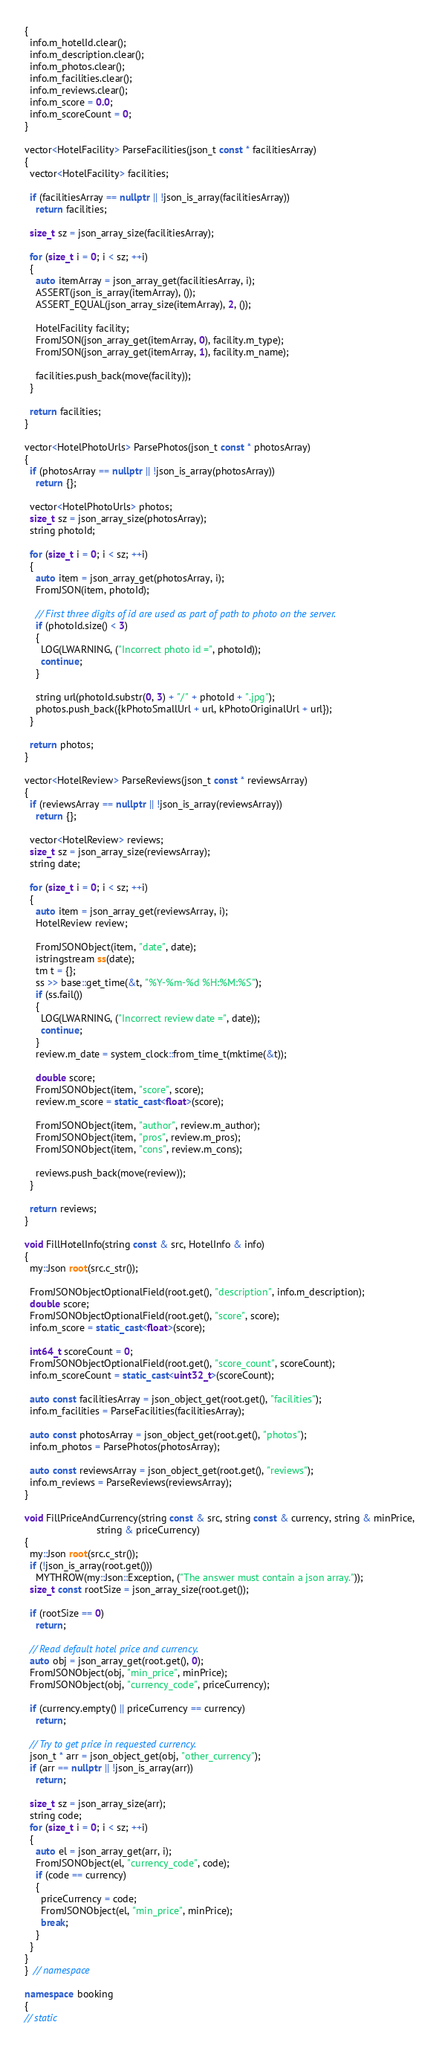Convert code to text. <code><loc_0><loc_0><loc_500><loc_500><_C++_>{
  info.m_hotelId.clear();
  info.m_description.clear();
  info.m_photos.clear();
  info.m_facilities.clear();
  info.m_reviews.clear();
  info.m_score = 0.0;
  info.m_scoreCount = 0;
}

vector<HotelFacility> ParseFacilities(json_t const * facilitiesArray)
{
  vector<HotelFacility> facilities;

  if (facilitiesArray == nullptr || !json_is_array(facilitiesArray))
    return facilities;

  size_t sz = json_array_size(facilitiesArray);

  for (size_t i = 0; i < sz; ++i)
  {
    auto itemArray = json_array_get(facilitiesArray, i);
    ASSERT(json_is_array(itemArray), ());
    ASSERT_EQUAL(json_array_size(itemArray), 2, ());

    HotelFacility facility;
    FromJSON(json_array_get(itemArray, 0), facility.m_type);
    FromJSON(json_array_get(itemArray, 1), facility.m_name);

    facilities.push_back(move(facility));
  }

  return facilities;
}

vector<HotelPhotoUrls> ParsePhotos(json_t const * photosArray)
{
  if (photosArray == nullptr || !json_is_array(photosArray))
    return {};

  vector<HotelPhotoUrls> photos;
  size_t sz = json_array_size(photosArray);
  string photoId;

  for (size_t i = 0; i < sz; ++i)
  {
    auto item = json_array_get(photosArray, i);
    FromJSON(item, photoId);

    // First three digits of id are used as part of path to photo on the server.
    if (photoId.size() < 3)
    {
      LOG(LWARNING, ("Incorrect photo id =", photoId));
      continue;
    }

    string url(photoId.substr(0, 3) + "/" + photoId + ".jpg");
    photos.push_back({kPhotoSmallUrl + url, kPhotoOriginalUrl + url});
  }

  return photos;
}

vector<HotelReview> ParseReviews(json_t const * reviewsArray)
{
  if (reviewsArray == nullptr || !json_is_array(reviewsArray))
    return {};

  vector<HotelReview> reviews;
  size_t sz = json_array_size(reviewsArray);
  string date;

  for (size_t i = 0; i < sz; ++i)
  {
    auto item = json_array_get(reviewsArray, i);
    HotelReview review;

    FromJSONObject(item, "date", date);
    istringstream ss(date);
    tm t = {};
    ss >> base::get_time(&t, "%Y-%m-%d %H:%M:%S");
    if (ss.fail())
    {
      LOG(LWARNING, ("Incorrect review date =", date));
      continue;
    }
    review.m_date = system_clock::from_time_t(mktime(&t));

    double score;
    FromJSONObject(item, "score", score);
    review.m_score = static_cast<float>(score);

    FromJSONObject(item, "author", review.m_author);
    FromJSONObject(item, "pros", review.m_pros);
    FromJSONObject(item, "cons", review.m_cons);

    reviews.push_back(move(review));
  }

  return reviews;
}

void FillHotelInfo(string const & src, HotelInfo & info)
{
  my::Json root(src.c_str());

  FromJSONObjectOptionalField(root.get(), "description", info.m_description);
  double score;
  FromJSONObjectOptionalField(root.get(), "score", score);
  info.m_score = static_cast<float>(score);

  int64_t scoreCount = 0;
  FromJSONObjectOptionalField(root.get(), "score_count", scoreCount);
  info.m_scoreCount = static_cast<uint32_t>(scoreCount);

  auto const facilitiesArray = json_object_get(root.get(), "facilities");
  info.m_facilities = ParseFacilities(facilitiesArray);

  auto const photosArray = json_object_get(root.get(), "photos");
  info.m_photos = ParsePhotos(photosArray);

  auto const reviewsArray = json_object_get(root.get(), "reviews");
  info.m_reviews = ParseReviews(reviewsArray);
}

void FillPriceAndCurrency(string const & src, string const & currency, string & minPrice,
                          string & priceCurrency)
{
  my::Json root(src.c_str());
  if (!json_is_array(root.get()))
    MYTHROW(my::Json::Exception, ("The answer must contain a json array."));
  size_t const rootSize = json_array_size(root.get());

  if (rootSize == 0)
    return;

  // Read default hotel price and currency.
  auto obj = json_array_get(root.get(), 0);
  FromJSONObject(obj, "min_price", minPrice);
  FromJSONObject(obj, "currency_code", priceCurrency);

  if (currency.empty() || priceCurrency == currency)
    return;

  // Try to get price in requested currency.
  json_t * arr = json_object_get(obj, "other_currency");
  if (arr == nullptr || !json_is_array(arr))
    return;

  size_t sz = json_array_size(arr);
  string code;
  for (size_t i = 0; i < sz; ++i)
  {
    auto el = json_array_get(arr, i);
    FromJSONObject(el, "currency_code", code);
    if (code == currency)
    {
      priceCurrency = code;
      FromJSONObject(el, "min_price", minPrice);
      break;
    }
  }
}
}  // namespace

namespace booking
{
// static</code> 